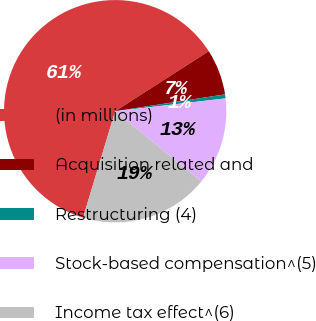<chart> <loc_0><loc_0><loc_500><loc_500><pie_chart><fcel>(in millions)<fcel>Acquisition related and<fcel>Restructuring (4)<fcel>Stock-based compensation^(5)<fcel>Income tax effect^(6)<nl><fcel>61.27%<fcel>6.65%<fcel>0.58%<fcel>12.72%<fcel>18.79%<nl></chart> 